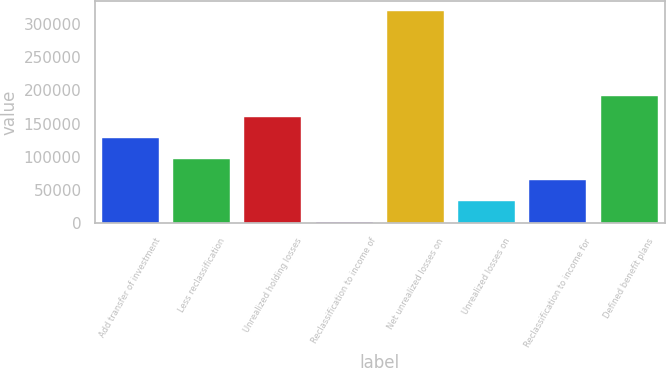<chart> <loc_0><loc_0><loc_500><loc_500><bar_chart><fcel>Add transfer of investment<fcel>Less reclassification<fcel>Unrealized holding losses<fcel>Reclassification to income of<fcel>Net unrealized losses on<fcel>Unrealized losses on<fcel>Reclassification to income for<fcel>Defined benefit plans<nl><fcel>128603<fcel>96906.6<fcel>160299<fcel>1818<fcel>318780<fcel>33514.2<fcel>65210.4<fcel>191995<nl></chart> 